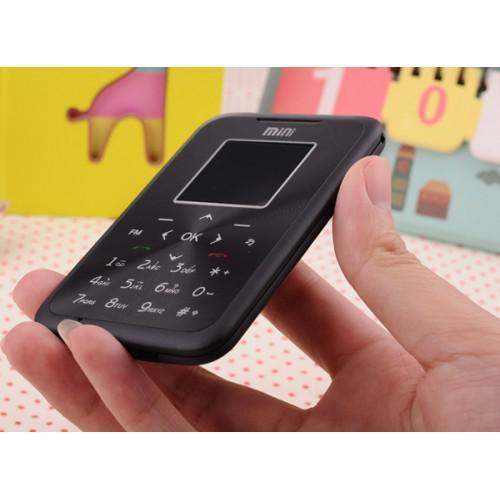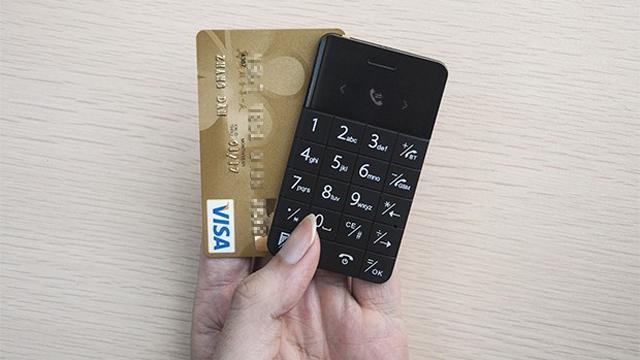The first image is the image on the left, the second image is the image on the right. Evaluate the accuracy of this statement regarding the images: "A person is holding a white device in the image on the left.". Is it true? Answer yes or no. No. The first image is the image on the left, the second image is the image on the right. For the images shown, is this caption "A person is holding something in the right image." true? Answer yes or no. Yes. 